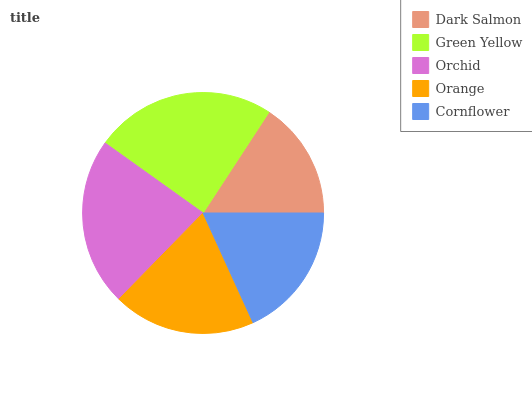Is Dark Salmon the minimum?
Answer yes or no. Yes. Is Green Yellow the maximum?
Answer yes or no. Yes. Is Orchid the minimum?
Answer yes or no. No. Is Orchid the maximum?
Answer yes or no. No. Is Green Yellow greater than Orchid?
Answer yes or no. Yes. Is Orchid less than Green Yellow?
Answer yes or no. Yes. Is Orchid greater than Green Yellow?
Answer yes or no. No. Is Green Yellow less than Orchid?
Answer yes or no. No. Is Orange the high median?
Answer yes or no. Yes. Is Orange the low median?
Answer yes or no. Yes. Is Orchid the high median?
Answer yes or no. No. Is Green Yellow the low median?
Answer yes or no. No. 